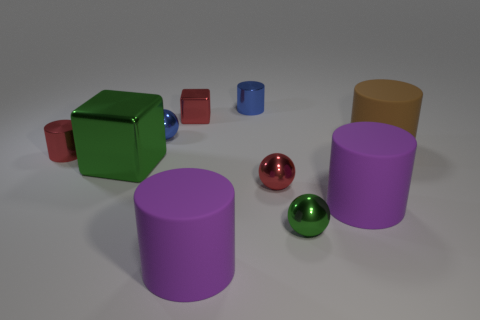Subtract all red metal cylinders. How many cylinders are left? 4 Subtract all red spheres. How many spheres are left? 2 Subtract 3 spheres. How many spheres are left? 0 Subtract all spheres. How many objects are left? 7 Subtract all brown cylinders. Subtract all purple balls. How many cylinders are left? 4 Subtract all blue cubes. How many purple cylinders are left? 2 Add 2 big cyan metal objects. How many big cyan metal objects exist? 2 Subtract 1 blue balls. How many objects are left? 9 Subtract all red shiny spheres. Subtract all small green things. How many objects are left? 8 Add 8 blue shiny cylinders. How many blue shiny cylinders are left? 9 